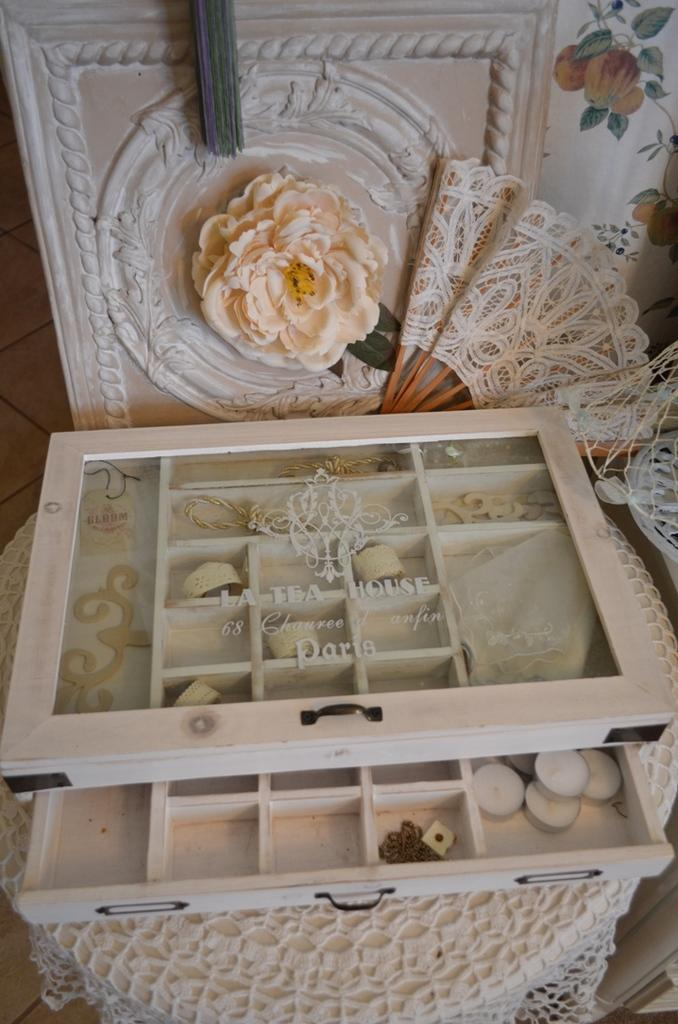What is the main object in the image? There is a box with different compartments in the image. What is placed inside the box? Candles are placed in the box. What can be seen in the background of the image? There is a cloth and a flower in the background of the image. How many cents are visible on the pen in the image? There is no pen or cent symbol present in the image. What type of street can be seen in the background of the image? There is no street visible in the image; it only shows a box with candles, a cloth, and a flower in the background. 